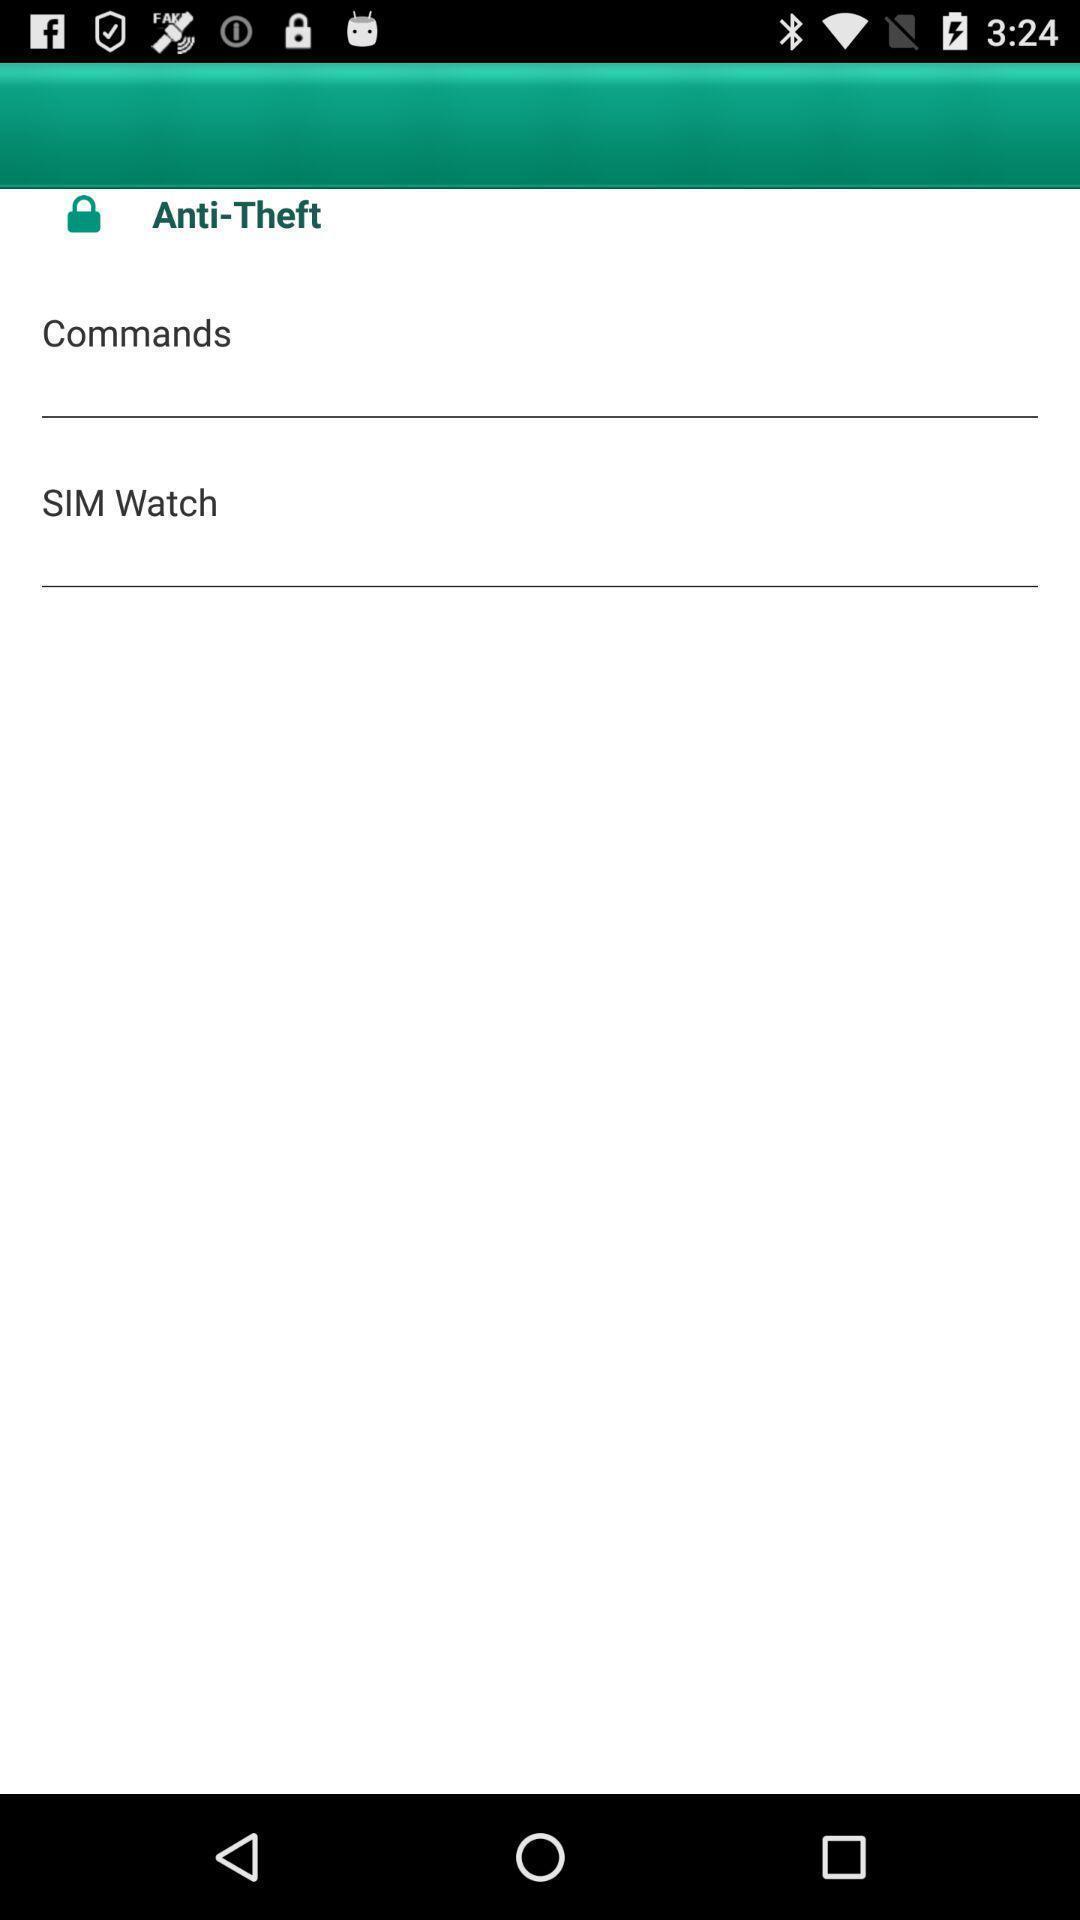What can you discern from this picture? Page with options to prevent conflict for application. 